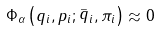Convert formula to latex. <formula><loc_0><loc_0><loc_500><loc_500>\Phi _ { \alpha } \left ( q _ { i } , p _ { i } ; \stackrel { \_ } { q } _ { i } , \pi _ { i } \right ) \approx 0</formula> 